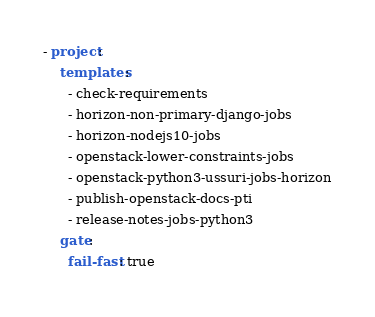Convert code to text. <code><loc_0><loc_0><loc_500><loc_500><_YAML_>- project:
    templates:
      - check-requirements
      - horizon-non-primary-django-jobs
      - horizon-nodejs10-jobs
      - openstack-lower-constraints-jobs
      - openstack-python3-ussuri-jobs-horizon
      - publish-openstack-docs-pti
      - release-notes-jobs-python3
    gate:
      fail-fast: true
</code> 